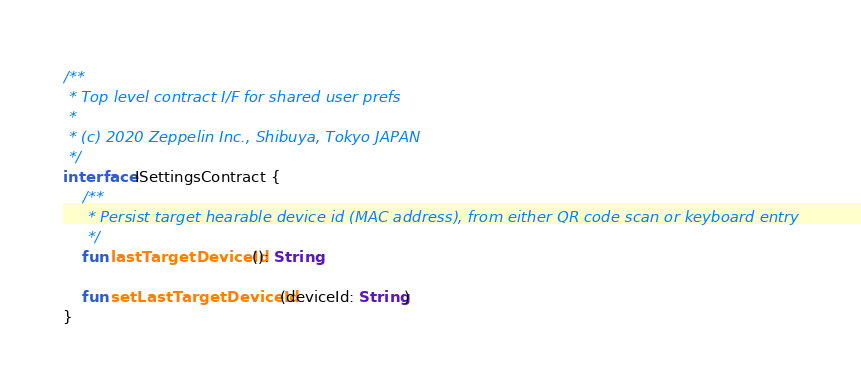<code> <loc_0><loc_0><loc_500><loc_500><_Kotlin_>
/**
 * Top level contract I/F for shared user prefs
 *
 * (c) 2020 Zeppelin Inc., Shibuya, Tokyo JAPAN
 */
interface ISettingsContract {
    /**
     * Persist target hearable device id (MAC address), from either QR code scan or keyboard entry
     */
    fun lastTargetDeviceId(): String

    fun setLastTargetDeviceId(deviceId: String)
}
</code> 